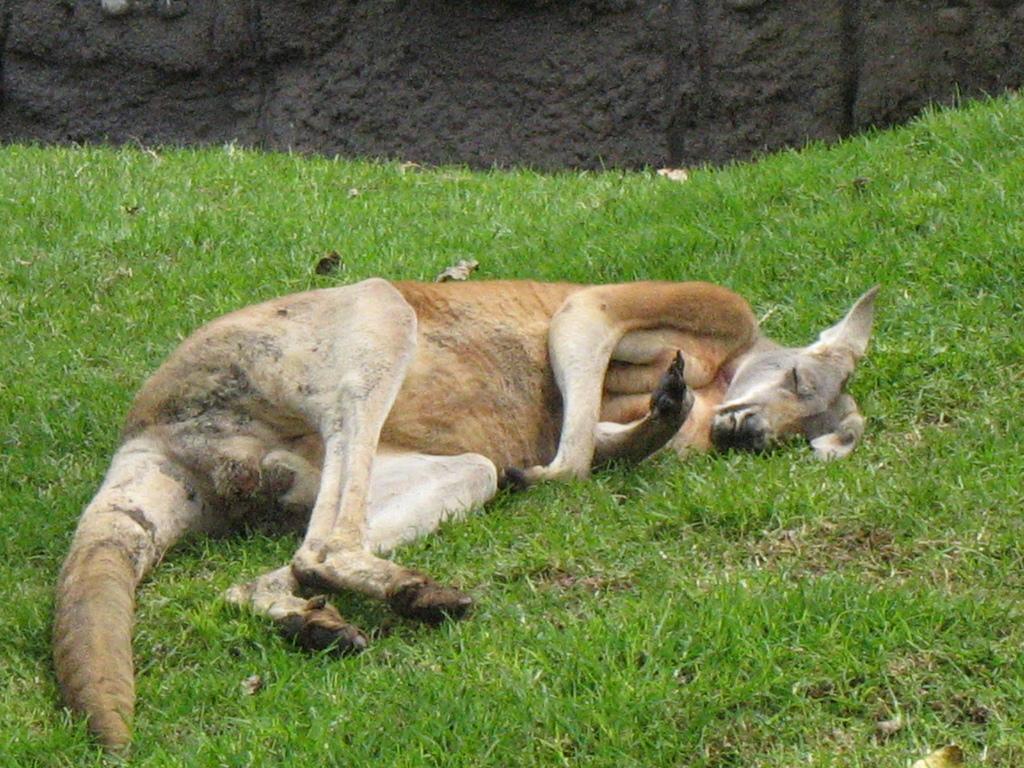Describe this image in one or two sentences. In this image in the foreground there is a kangaroo sleeping on the ground, and the ground is full of grass. 